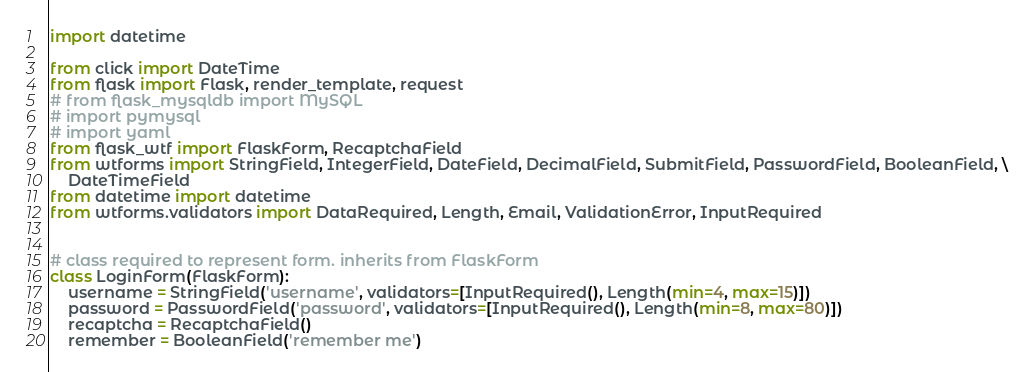Convert code to text. <code><loc_0><loc_0><loc_500><loc_500><_Python_>import datetime

from click import DateTime
from flask import Flask, render_template, request
# from flask_mysqldb import MySQL
# import pymysql
# import yaml
from flask_wtf import FlaskForm, RecaptchaField
from wtforms import StringField, IntegerField, DateField, DecimalField, SubmitField, PasswordField, BooleanField, \
    DateTimeField
from datetime import datetime
from wtforms.validators import DataRequired, Length, Email, ValidationError, InputRequired


# class required to represent form. inherits from FlaskForm
class LoginForm(FlaskForm):
    username = StringField('username', validators=[InputRequired(), Length(min=4, max=15)])
    password = PasswordField('password', validators=[InputRequired(), Length(min=8, max=80)])
    recaptcha = RecaptchaField()
    remember = BooleanField('remember me')

</code> 